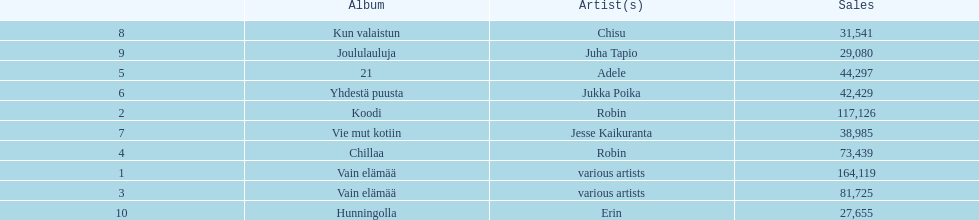Which album has the highest number of sales but doesn't have a designated artist? Vain elämää. 